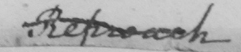Can you read and transcribe this handwriting? Reproach 